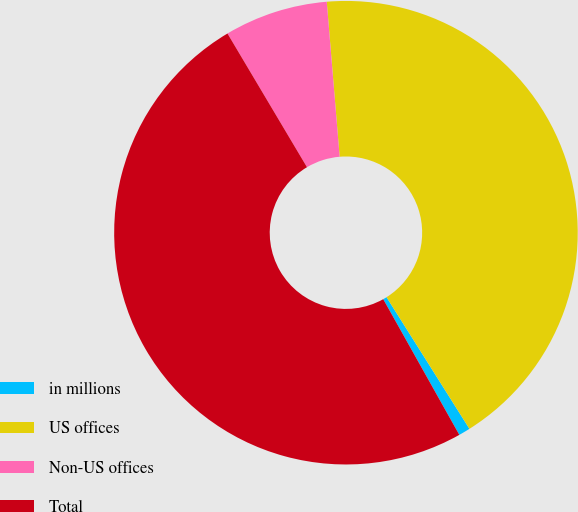Convert chart. <chart><loc_0><loc_0><loc_500><loc_500><pie_chart><fcel>in millions<fcel>US offices<fcel>Non-US offices<fcel>Total<nl><fcel>0.81%<fcel>42.38%<fcel>7.22%<fcel>49.6%<nl></chart> 